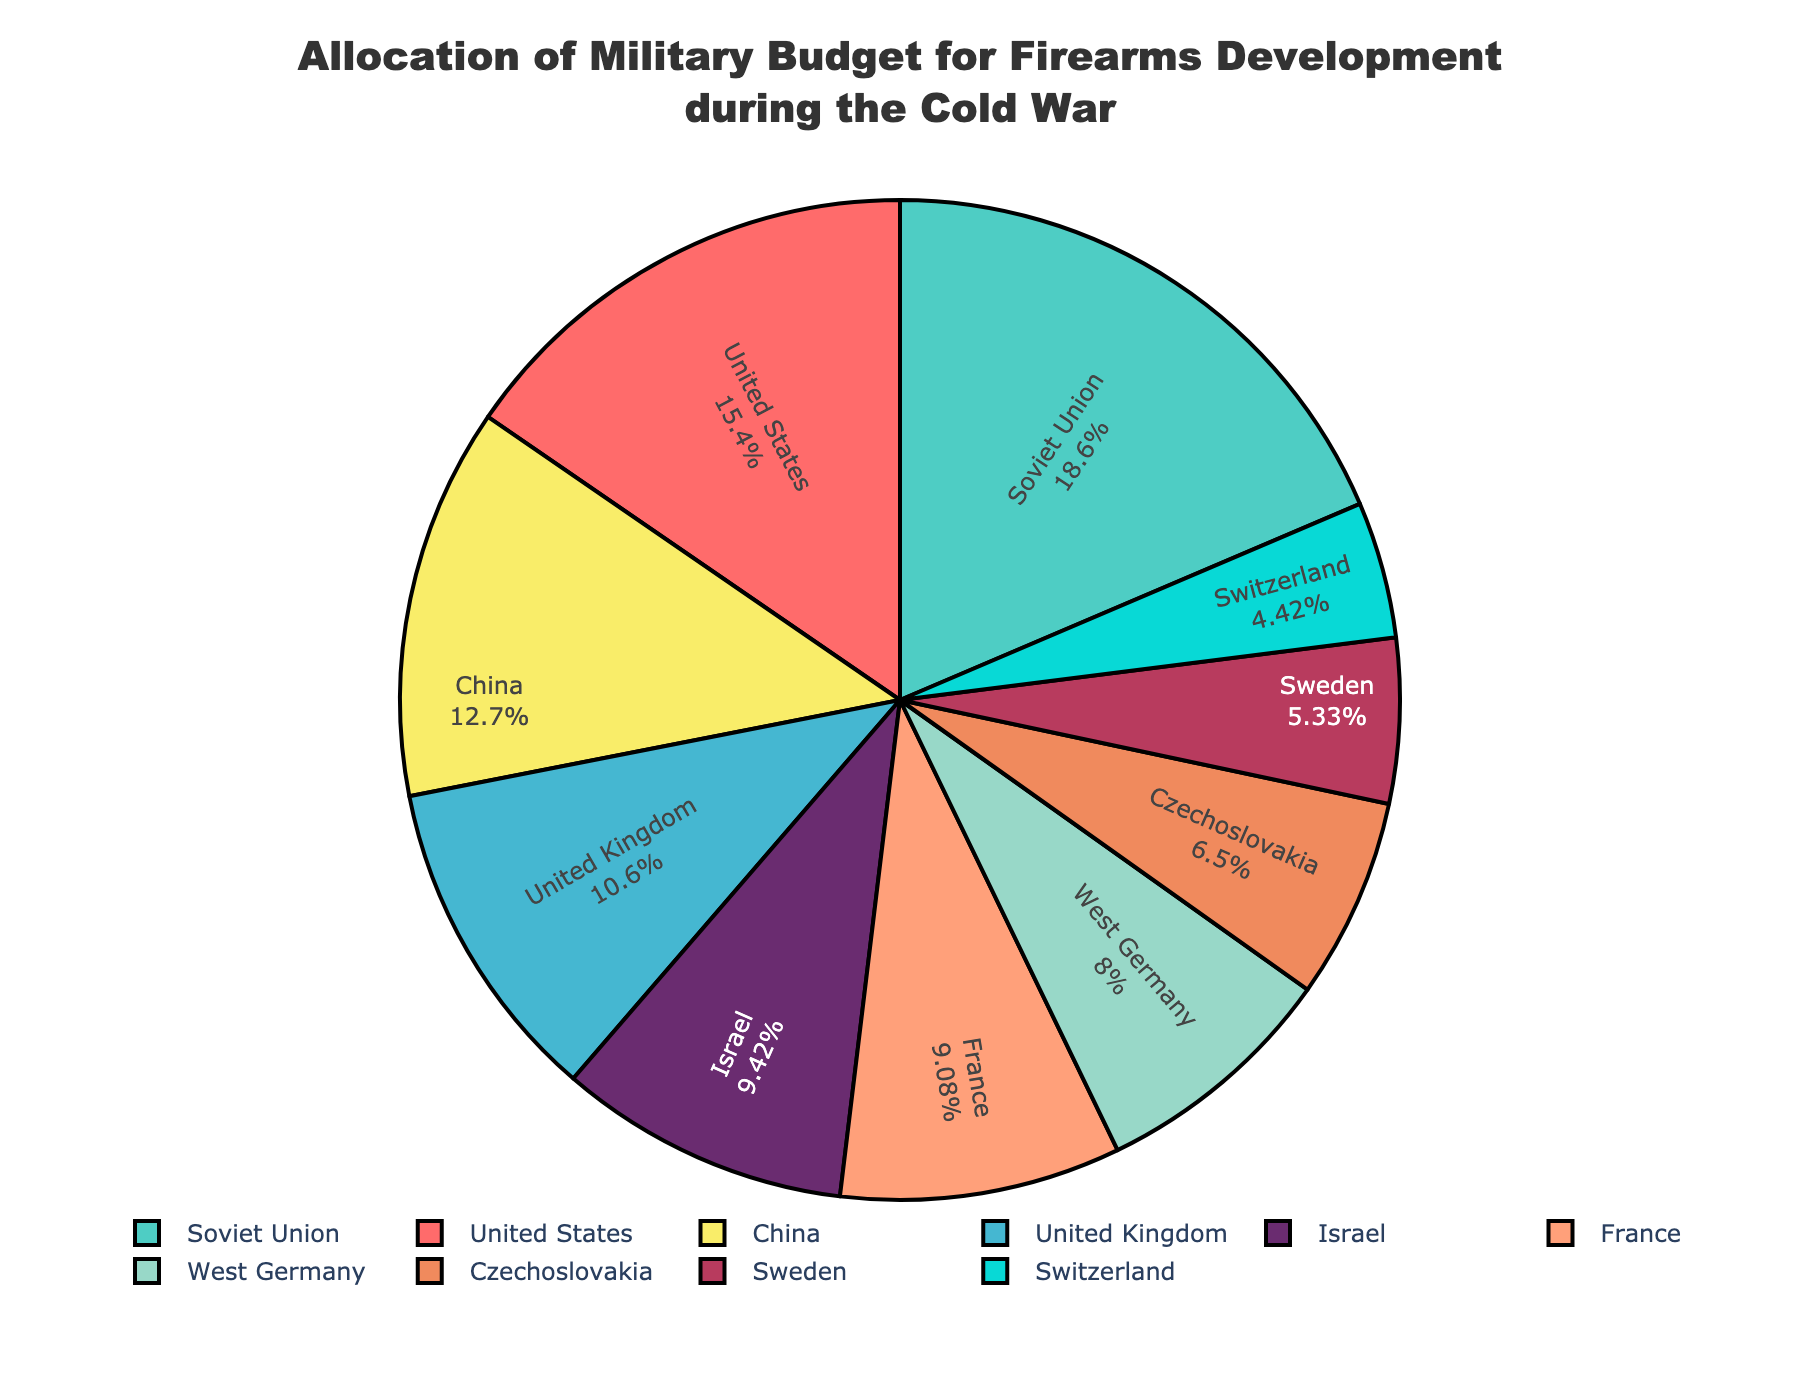Which country allocated the highest percentage of its military budget for firearms development during the Cold War? The Soviet Union allocated the highest percentage. By examining the figure, it's evident that the Soviet Union has the largest slice of the pie chart, with 22.3%.
Answer: Soviet Union Which country allocated a lower percentage of its military budget for firearms development, France or Israel? France allocated a lower percentage for firearms development than Israel. The pie chart indicates that France allocated 10.9% while Israel allocated 11.3%.
Answer: France What is the combined percentage of the military budget for firearms development for the United States and China? To find the combined percentage, sum the individual percentages for the United States and China, which are 18.5% and 15.2%, respectively. This results in 18.5 + 15.2 = 33.7%.
Answer: 33.7% Which country has the smallest allocation in the military budget for firearms development? Switzerland has the smallest allocation. According to the figure, Switzerland has a 5.3% allocation, the smallest slice of the pie chart.
Answer: Switzerland Is the percentage of military budget allocation for firearms development of the United Kingdom greater than the combined allocations of Sweden and Czechoslovakia? To determine this, compare the percentage for the United Kingdom (12.7%) with the combined percentages for Sweden (6.4%) and Czechoslovakia (7.8%). The combined allocation for Sweden and Czechoslovakia is 6.4 + 7.8 = 14.2%, which is greater than the United Kingdom at 12.7%.
Answer: No What is the average allocation of military budgets for firearms development among all the countries listed? First, sum the percentages of all the countries: 18.5 + 22.3 + 12.7 + 10.9 + 9.6 + 15.2 + 7.8 + 6.4 + 11.3 + 5.3 = 120.0%. Then, divide by the number of countries, which is 10. The average is 120.0 / 10 = 12%.
Answer: 12% Which countries have an allocation of the military budget for firearms development that is below the average of all countries listed? The average allocation is 12%. The countries below this average are France (10.9%), West Germany (9.6%), Czechoslovakia (7.8%), Sweden (6.4%), and Switzerland (5.3%).
Answer: France, West Germany, Czechoslovakia, Sweden, Switzerland How much greater is the allocation for firearms development in the Soviet Union compared to Switzerland? Subtract Switzerland's allocation (5.3%) from the Soviet Union's allocation (22.3%). The difference is 22.3 - 5.3 = 17.0%.
Answer: 17.0% 